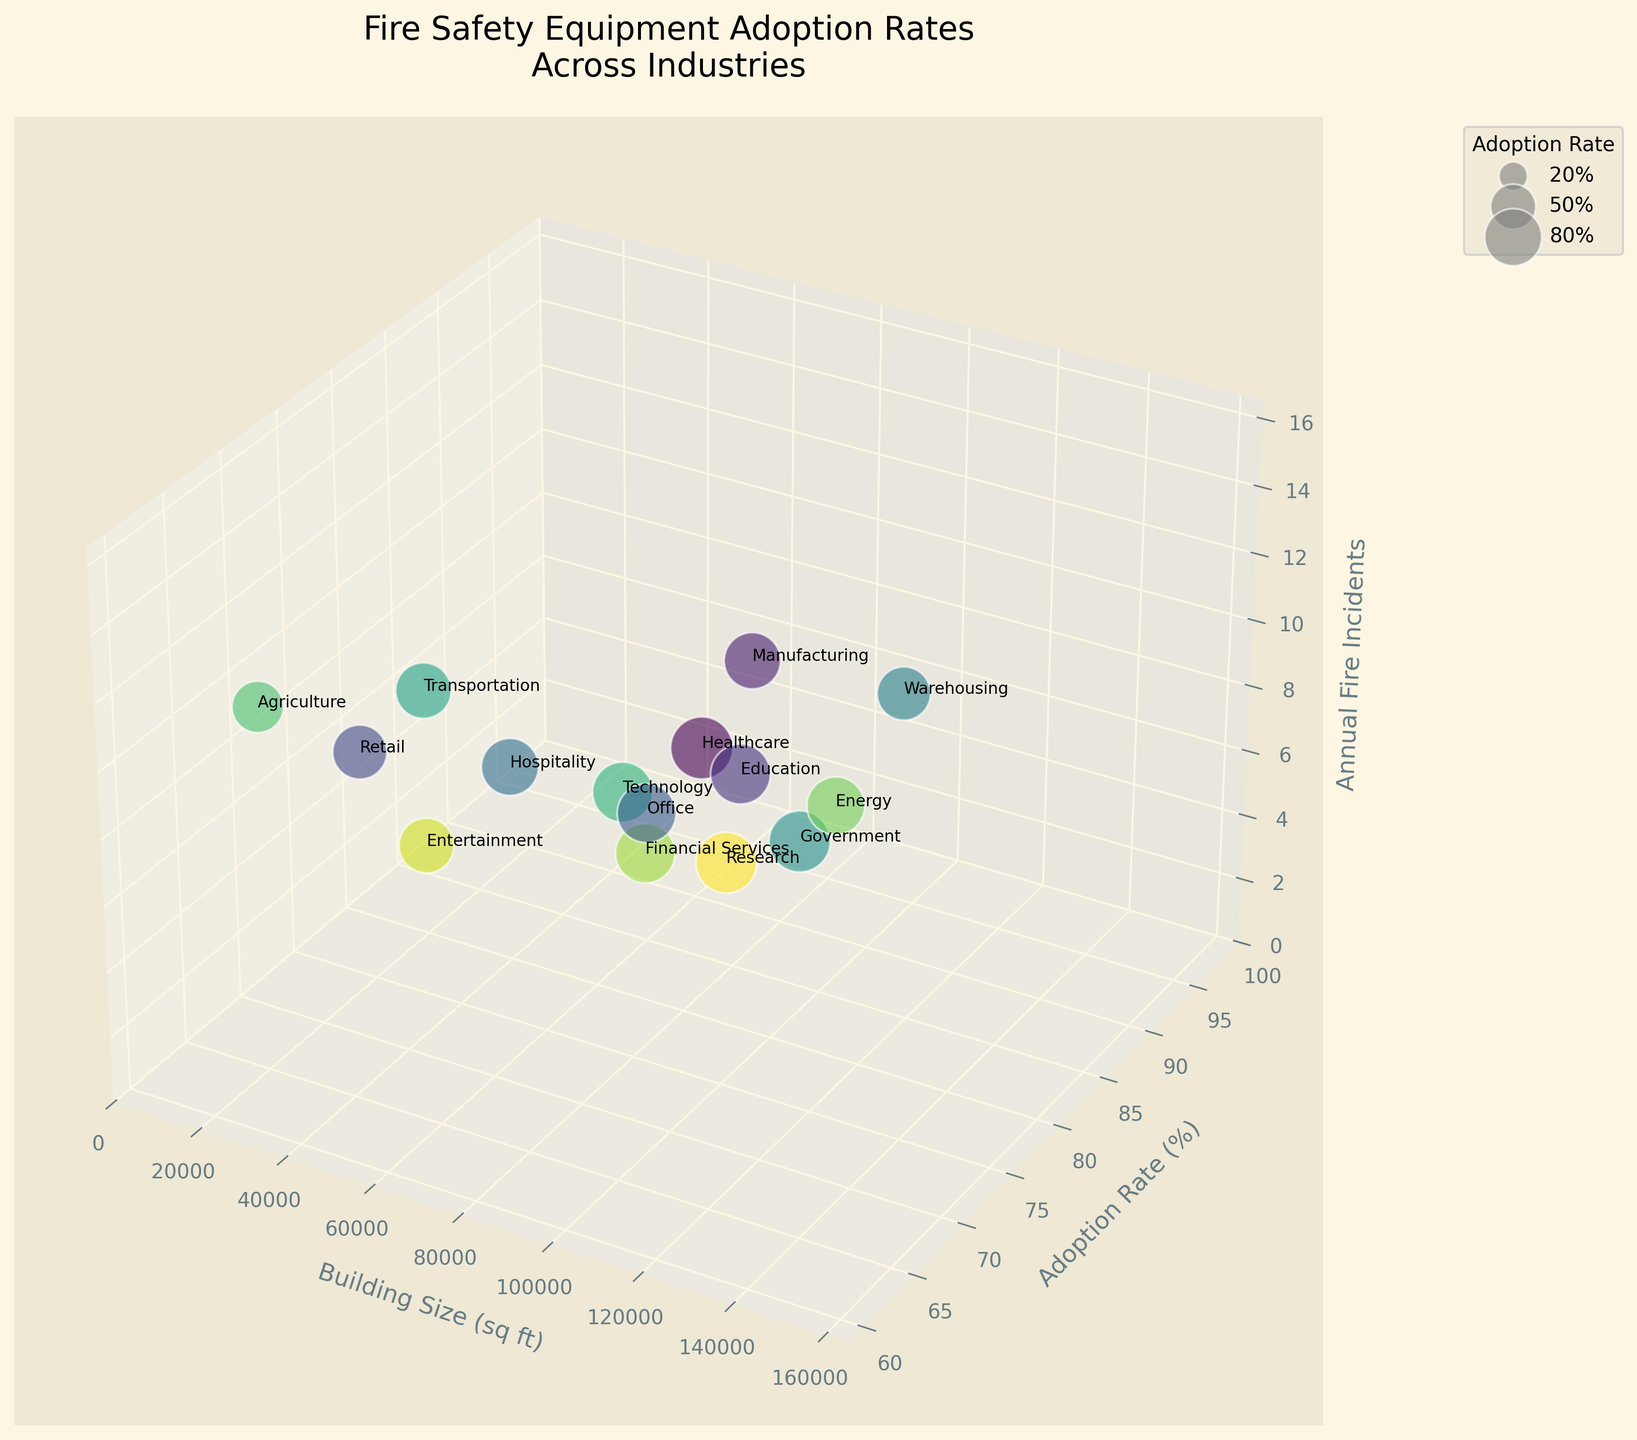What's the title of the figure? The title of the figure is displayed at the top and reads "Fire Safety Equipment Adoption Rates Across Industries."
Answer: Fire Safety Equipment Adoption Rates Across Industries What is the x-axis representing? The label of the x-axis specifies that it represents "Building Size (sq ft)."
Answer: Building Size (sq ft) Which industries have the highest and lowest adoption rates? By observing the y-axis, the highest adoption rate is 95% for Healthcare and the lowest adoption rate is 65% for Agriculture.
Answer: Healthcare (95%), Agriculture (65%) How many annual fire incidents does the Manufacturing industry experience? The z-axis represents annual fire incidents, and the bubble labeled "Manufacturing" is at the 12 mark on the z-axis.
Answer: 12 What are the building sizes for the Retail and Warehousing industries? The x-axis represents building size in square feet. Retail is at 25,000 sq ft, while Warehousing is at 150,000 sq ft.
Answer: Retail: 25,000 sq ft, Warehousing: 150,000 sq ft Which industry has the highest number of annual fire incidents, and what is its adoption rate? The Warehousing industry is at the highest z-value (15 annual fire incidents) with an adoption rate of 70%.
Answer: Warehousing, 70% Compare the number of annual fire incidents in the Healthcare and Office industries. By examining their positions on the z-axis, Healthcare is around 3, and Office is around 4 annual fire incidents.
Answer: Healthcare: 3, Office: 4 What regions are represented in the figure, and which has the highest adoption rate? The regions are mentioned alongside industries. New England has the highest adoption rate at 92% (Government industry).
Answer: New England (Government industry) Identify the industries with an adoption rate between 75% and 80% and their associated regions. The industries within this range are Hospitality (80%, Pacific Northwest) and Transportation (76%, Mid-Atlantic).
Answer: Hospitality (Pacific Northwest), Transportation (Mid-Atlantic) Which industry in the Midwest US is shown and what is its building size? The Midwest US region is referenced with the Manufacturing industry, which has a building size of 100,000 sq ft.
Answer: Manufacturing, 100,000 sq ft 